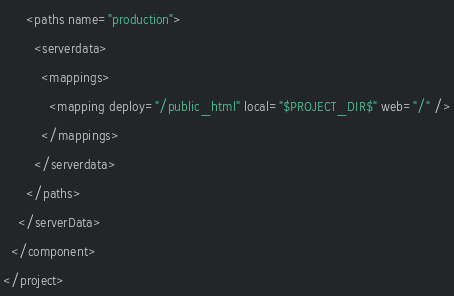Convert code to text. <code><loc_0><loc_0><loc_500><loc_500><_XML_>      <paths name="production">
        <serverdata>
          <mappings>
            <mapping deploy="/public_html" local="$PROJECT_DIR$" web="/" />
          </mappings>
        </serverdata>
      </paths>
    </serverData>
  </component>
</project></code> 